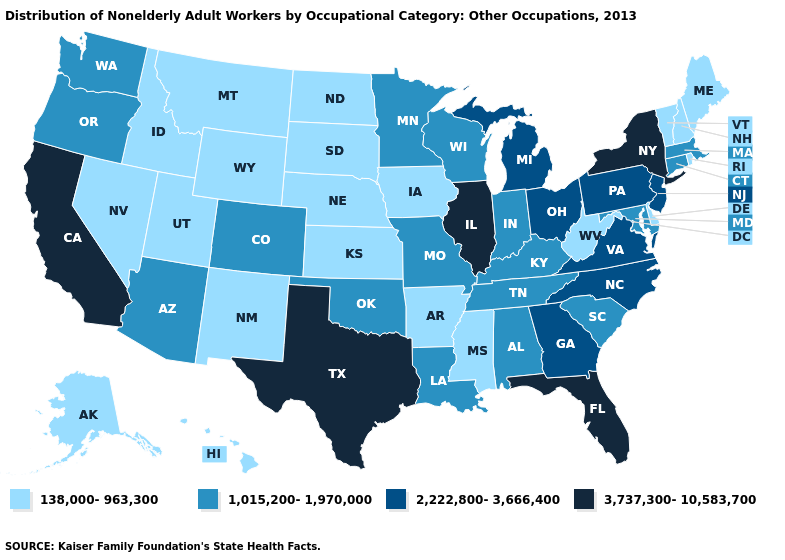Which states have the lowest value in the USA?
Be succinct. Alaska, Arkansas, Delaware, Hawaii, Idaho, Iowa, Kansas, Maine, Mississippi, Montana, Nebraska, Nevada, New Hampshire, New Mexico, North Dakota, Rhode Island, South Dakota, Utah, Vermont, West Virginia, Wyoming. What is the highest value in the South ?
Answer briefly. 3,737,300-10,583,700. Does the first symbol in the legend represent the smallest category?
Write a very short answer. Yes. Does Vermont have the highest value in the USA?
Short answer required. No. What is the highest value in the South ?
Write a very short answer. 3,737,300-10,583,700. What is the highest value in states that border Florida?
Quick response, please. 2,222,800-3,666,400. Name the states that have a value in the range 138,000-963,300?
Give a very brief answer. Alaska, Arkansas, Delaware, Hawaii, Idaho, Iowa, Kansas, Maine, Mississippi, Montana, Nebraska, Nevada, New Hampshire, New Mexico, North Dakota, Rhode Island, South Dakota, Utah, Vermont, West Virginia, Wyoming. What is the highest value in states that border Oregon?
Short answer required. 3,737,300-10,583,700. Does the map have missing data?
Be succinct. No. What is the value of Oklahoma?
Keep it brief. 1,015,200-1,970,000. Does Kentucky have the lowest value in the South?
Short answer required. No. Does Tennessee have the same value as Michigan?
Keep it brief. No. What is the value of North Dakota?
Concise answer only. 138,000-963,300. Name the states that have a value in the range 138,000-963,300?
Short answer required. Alaska, Arkansas, Delaware, Hawaii, Idaho, Iowa, Kansas, Maine, Mississippi, Montana, Nebraska, Nevada, New Hampshire, New Mexico, North Dakota, Rhode Island, South Dakota, Utah, Vermont, West Virginia, Wyoming. 